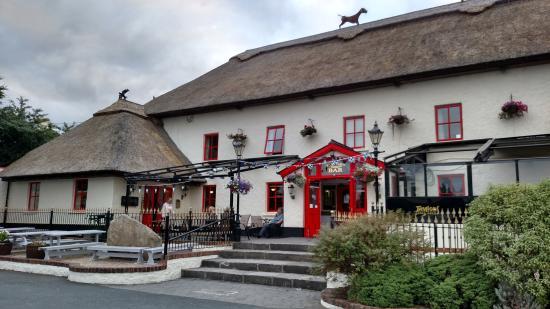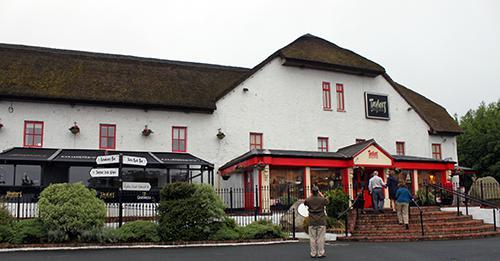The first image is the image on the left, the second image is the image on the right. Evaluate the accuracy of this statement regarding the images: "In one image, at least one rightward-facing dog figure is on the rooftop of a large, pale colored building with red entrance doors.". Is it true? Answer yes or no. Yes. 